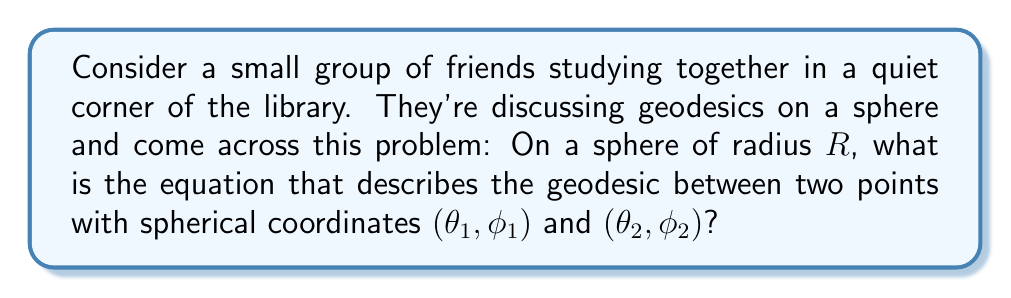What is the answer to this math problem? Let's approach this step-by-step:

1) First, recall that geodesics on a sphere are great circles, which are formed by the intersection of the sphere with a plane passing through the center of the sphere.

2) The general equation of a great circle on a sphere in spherical coordinates is:

   $$\tan(\theta) = \frac{\cos(\alpha)\sin(\phi - \beta)}{\sin(\alpha)\cos(\phi) - \cos(\alpha)\sin(\phi)\cos(\beta)}$$

   where $\alpha$ and $\beta$ are constants that depend on the two points.

3) To find $\alpha$ and $\beta$, we can use the given points $(\theta_1, \phi_1)$ and $(\theta_2, \phi_2)$:

   $$\tan(\alpha) = \frac{\cos(\theta_1)\sin(\theta_2) - \sin(\theta_1)\cos(\theta_2)\cos(\phi_2 - \phi_1)}{\sin(\theta_2)\sin(\phi_2 - \phi_1)}$$

   $$\tan(\beta) = \frac{\tan(\phi_2)\cos(\theta_2) - \tan(\phi_1)\cos(\theta_1)}{\sin(\theta_2 - \theta_1)}$$

4) Once we have $\alpha$ and $\beta$, we can substitute them into the general equation to get the specific equation of the geodesic passing through our two points.

5) Note that the radius $R$ doesn't appear in this equation because it only affects the scale, not the shape of the geodesic.

6) This equation completely describes the geodesic between the two points on the sphere.
Answer: $$\tan(\theta) = \frac{\cos(\alpha)\sin(\phi - \beta)}{\sin(\alpha)\cos(\phi) - \cos(\alpha)\sin(\phi)\cos(\beta)}$$ 